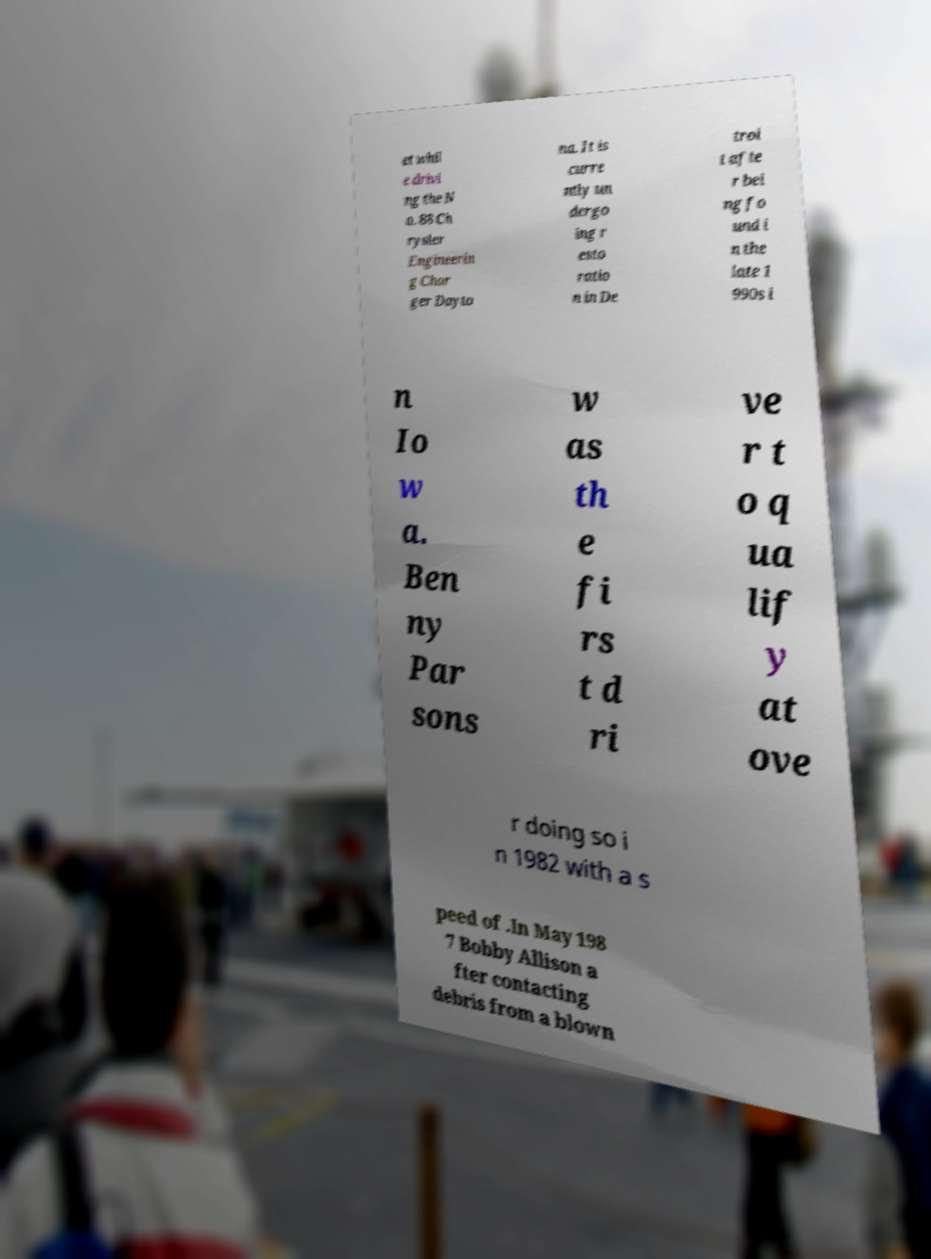What messages or text are displayed in this image? I need them in a readable, typed format. et whil e drivi ng the N o. 88 Ch rysler Engineerin g Char ger Dayto na. It is curre ntly un dergo ing r esto ratio n in De troi t afte r bei ng fo und i n the late 1 990s i n Io w a. Ben ny Par sons w as th e fi rs t d ri ve r t o q ua lif y at ove r doing so i n 1982 with a s peed of .In May 198 7 Bobby Allison a fter contacting debris from a blown 